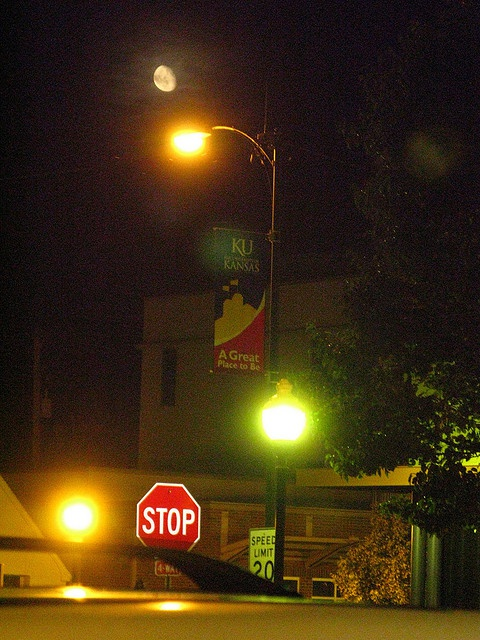Describe the objects in this image and their specific colors. I can see car in black, olive, and maroon tones, stop sign in black, red, ivory, and maroon tones, and traffic light in black, white, yellow, and olive tones in this image. 